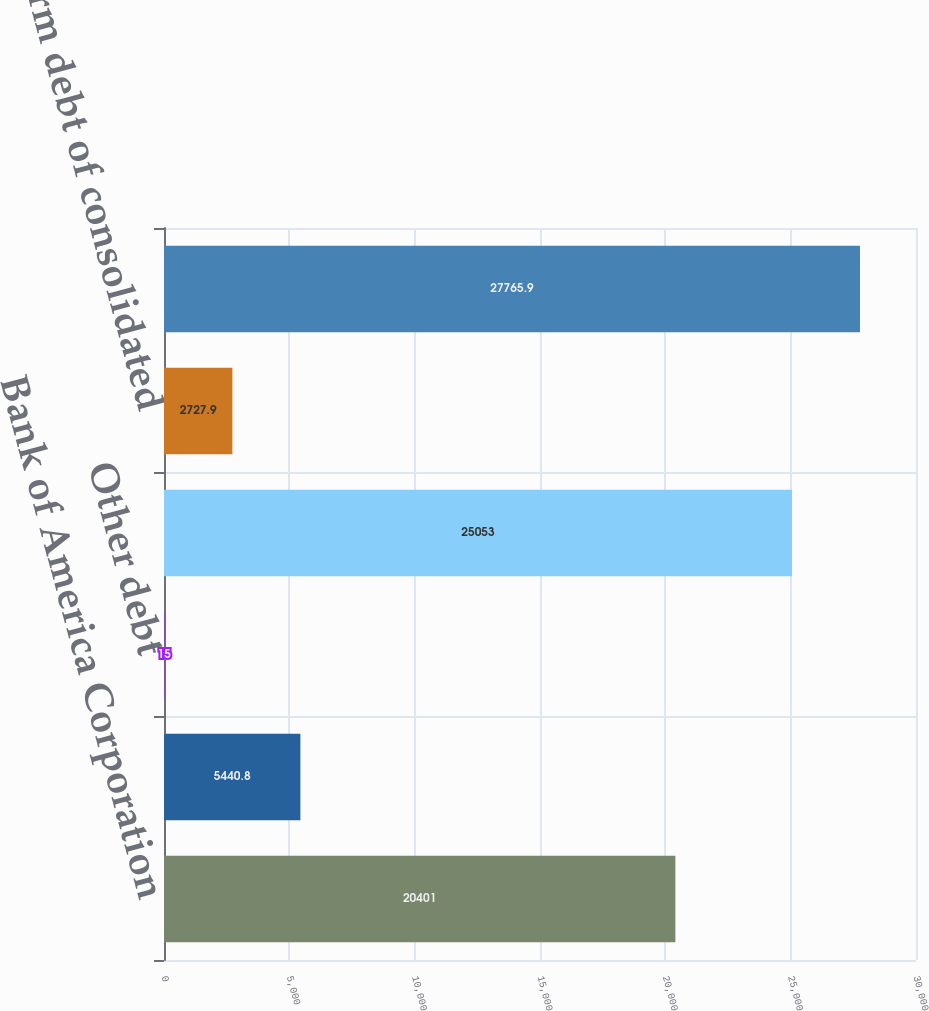Convert chart to OTSL. <chart><loc_0><loc_0><loc_500><loc_500><bar_chart><fcel>Bank of America Corporation<fcel>Merrill Lynch & Co Inc and<fcel>Other debt<fcel>Total long-term debt excluding<fcel>Long-term debt of consolidated<fcel>Total long-term debt<nl><fcel>20401<fcel>5440.8<fcel>15<fcel>25053<fcel>2727.9<fcel>27765.9<nl></chart> 